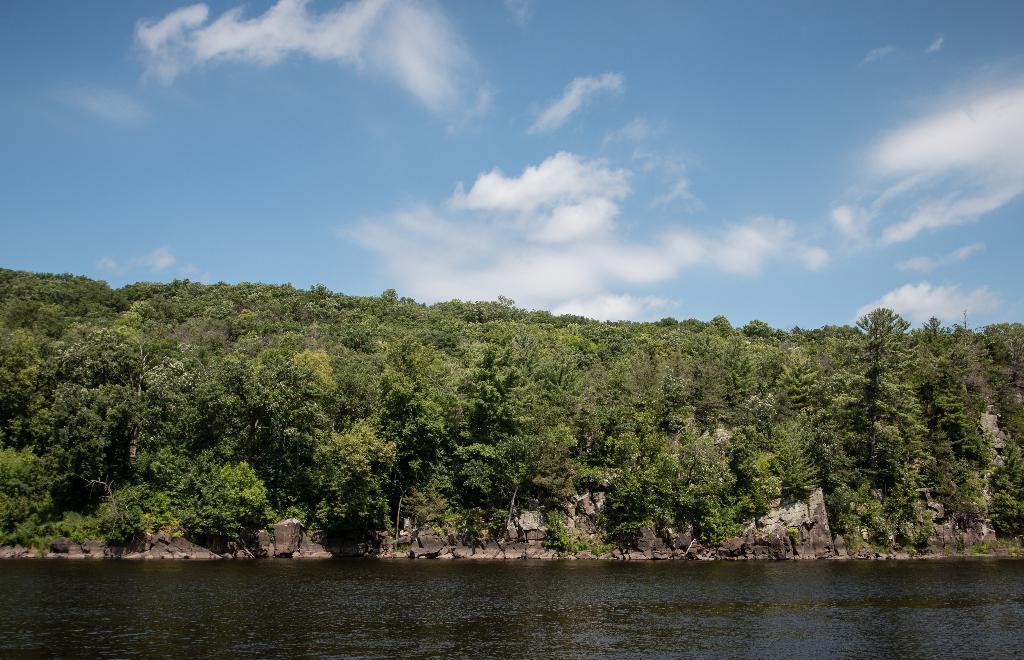Please provide a concise description of this image. In this image we can see water and trees. In the background there is sky with clouds. 